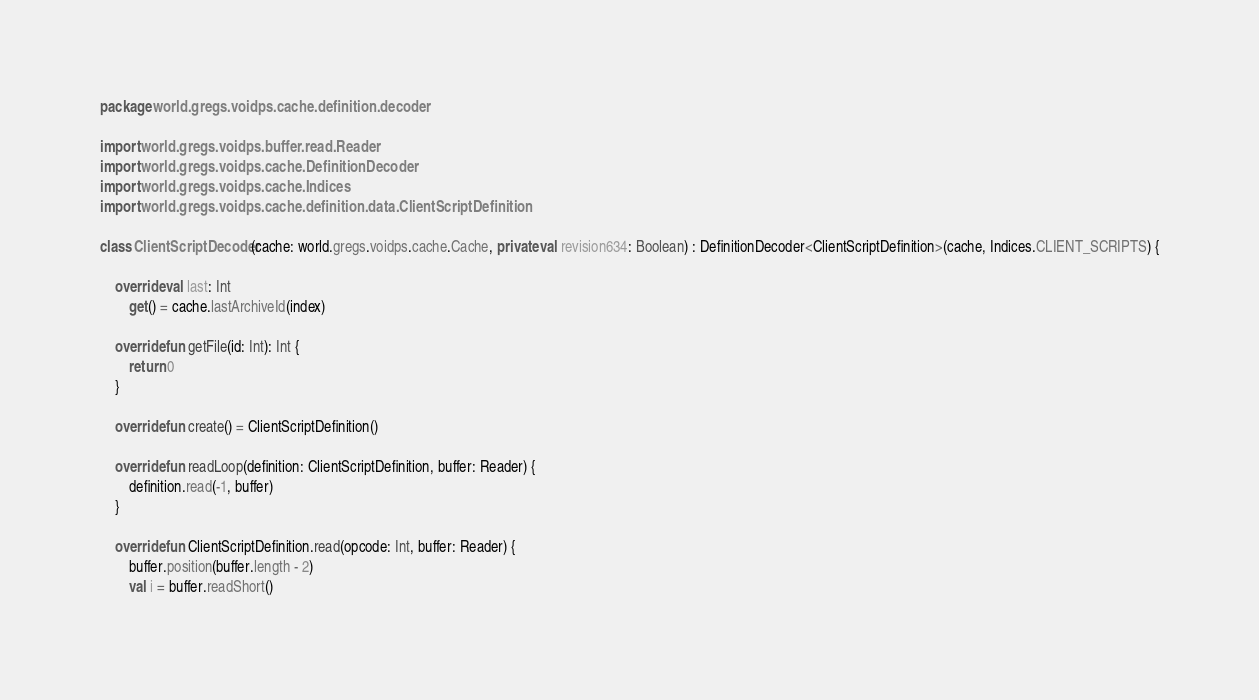Convert code to text. <code><loc_0><loc_0><loc_500><loc_500><_Kotlin_>package world.gregs.voidps.cache.definition.decoder

import world.gregs.voidps.buffer.read.Reader
import world.gregs.voidps.cache.DefinitionDecoder
import world.gregs.voidps.cache.Indices
import world.gregs.voidps.cache.definition.data.ClientScriptDefinition

class ClientScriptDecoder(cache: world.gregs.voidps.cache.Cache, private val revision634: Boolean) : DefinitionDecoder<ClientScriptDefinition>(cache, Indices.CLIENT_SCRIPTS) {

    override val last: Int
        get() = cache.lastArchiveId(index)

    override fun getFile(id: Int): Int {
        return 0
    }

    override fun create() = ClientScriptDefinition()

    override fun readLoop(definition: ClientScriptDefinition, buffer: Reader) {
        definition.read(-1, buffer)
    }

    override fun ClientScriptDefinition.read(opcode: Int, buffer: Reader) {
        buffer.position(buffer.length - 2)
        val i = buffer.readShort()</code> 